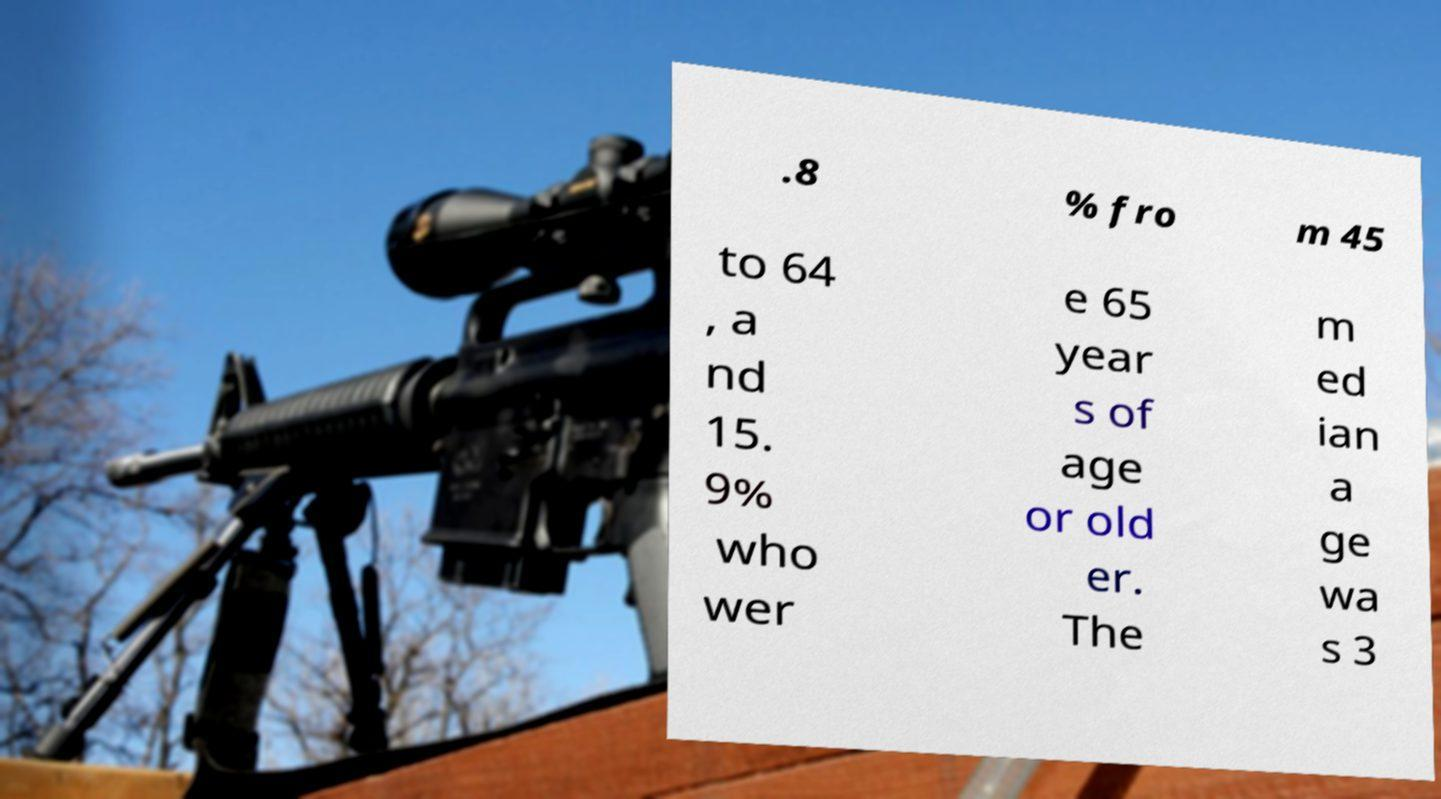There's text embedded in this image that I need extracted. Can you transcribe it verbatim? .8 % fro m 45 to 64 , a nd 15. 9% who wer e 65 year s of age or old er. The m ed ian a ge wa s 3 